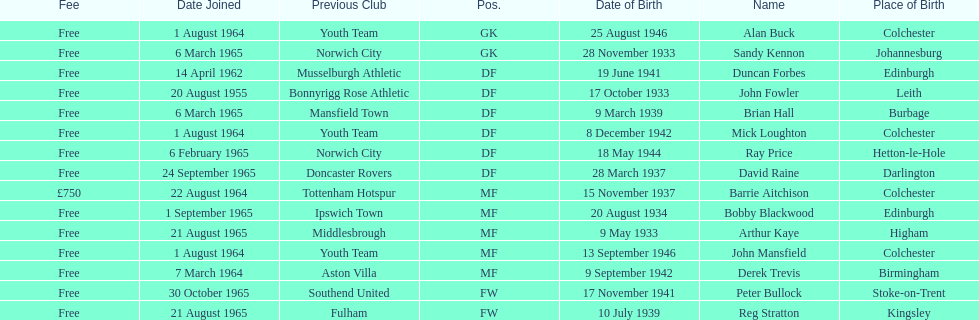Is arthur kaye senior or junior in comparison to brian hill? Older. 